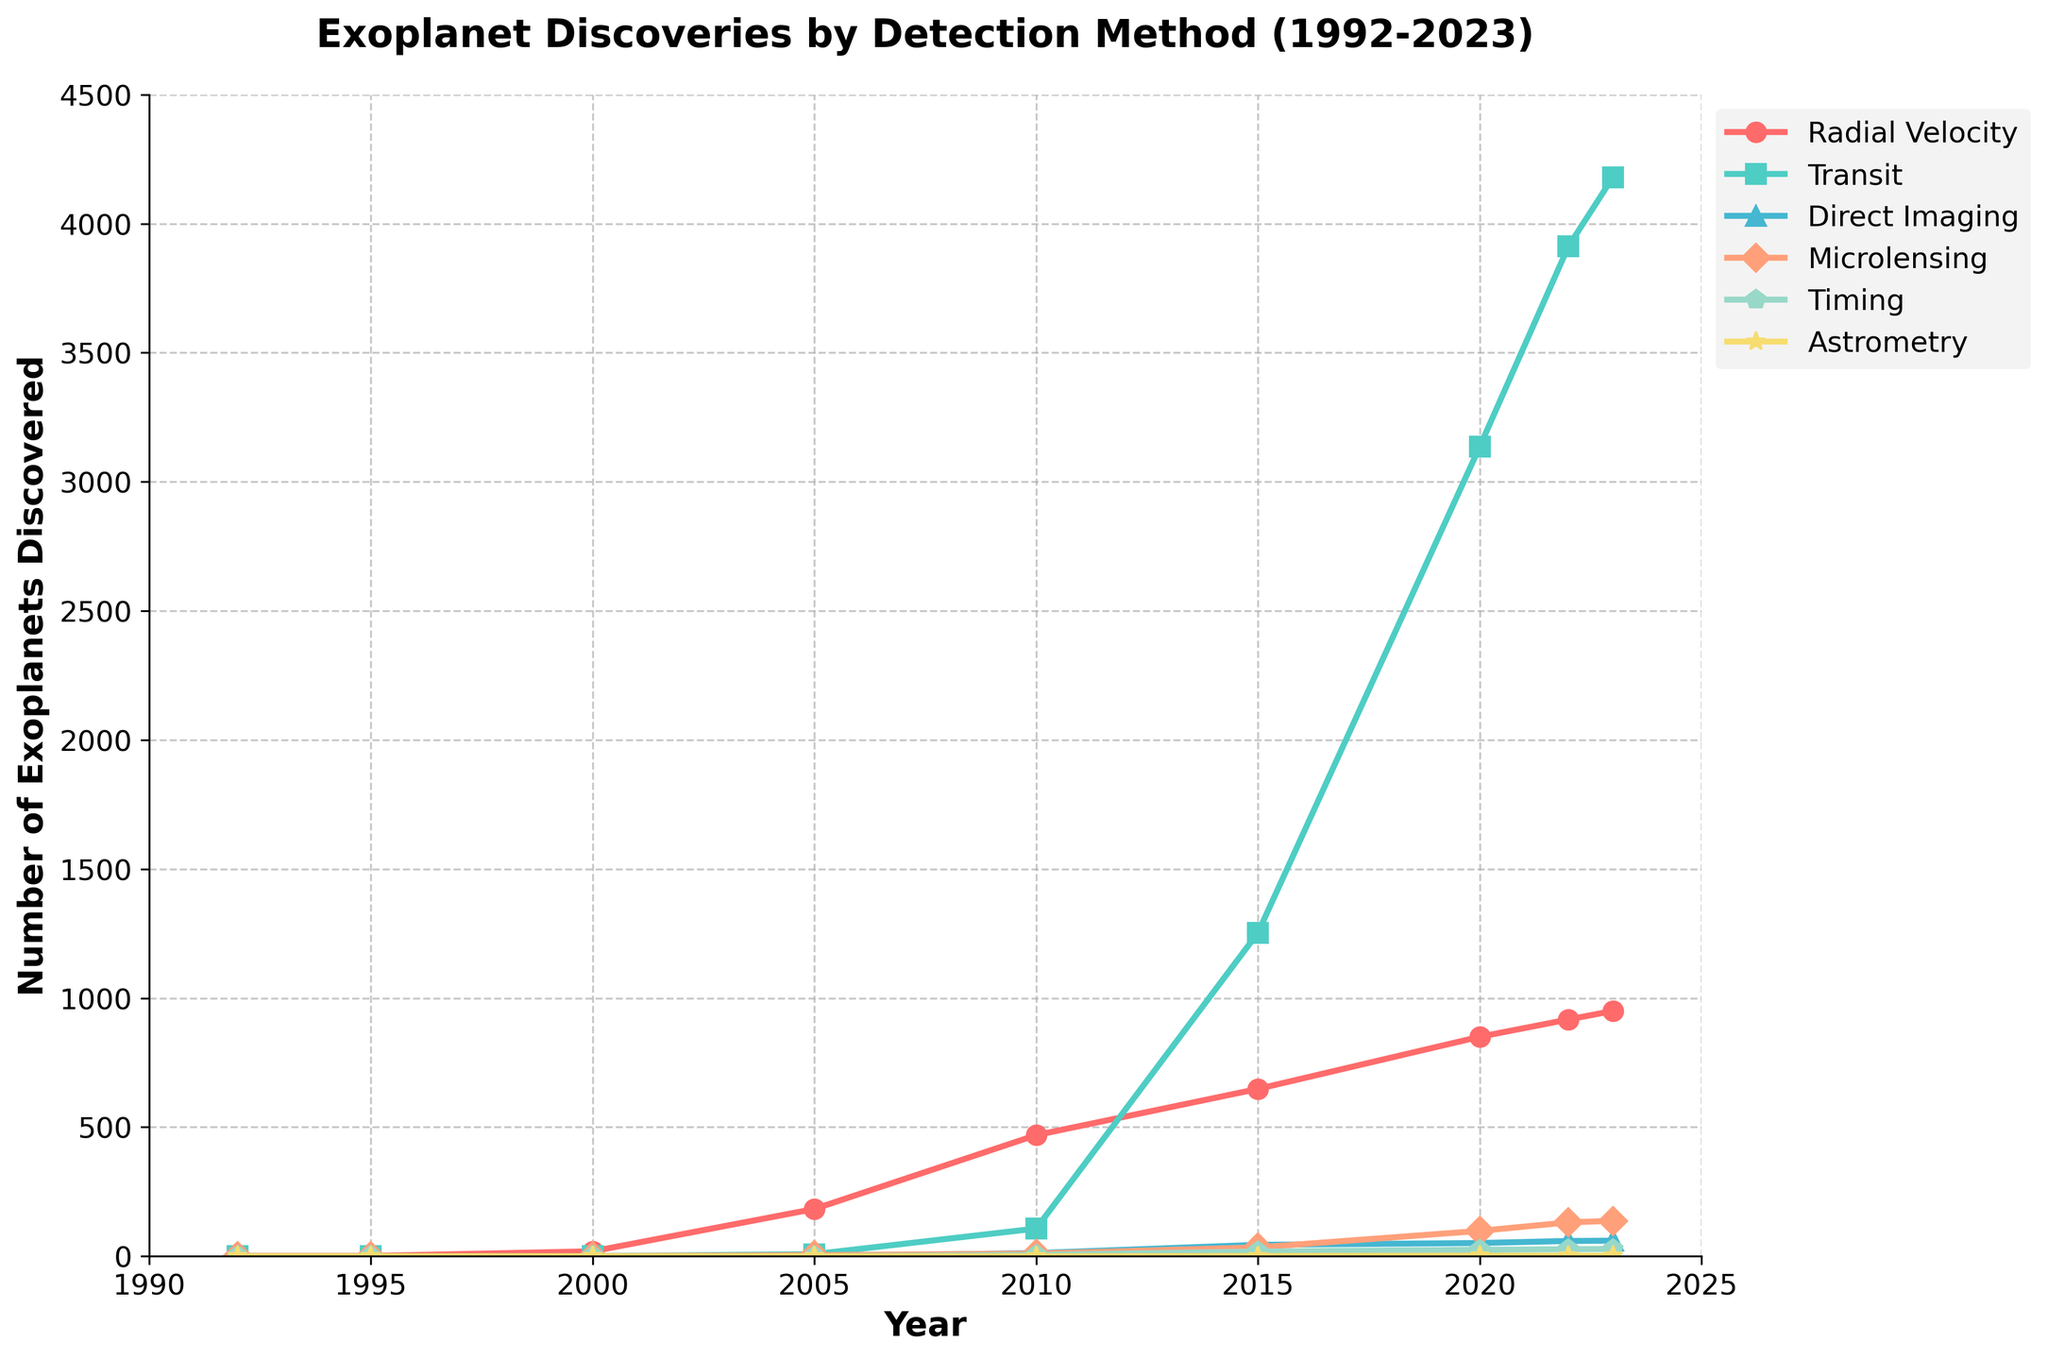What is the most common detection method used for discovering exoplanets in 2023? By looking at the data, we can see that in 2023, the "Transit" method has the highest value, which is 4179. Therefore, it is the most common detection method in 2023.
Answer: Transit Which year shows the highest number of exoplanets discovered using the Transit method? By examining the plot, we can see that 2023 has the highest number of exoplanets discovered using the Transit method, with a value of 4179.
Answer: 2023 How many exoplanets were discovered using Radial Velocity and Transit methods combined in 2015? In 2015, the number of exoplanets discovered using Radial Velocity is 648 and using Transit is 1253. Adding these, 648 + 1253 = 1901.
Answer: 1901 Compare the number of exoplanets discovered using Microlensing in 2020 and 2022. Which year had more discoveries? Checking the data for Microlensing, in 2020 it was 98 and in 2022 it was 131. Therefore, more discoveries were made using Microlensing in 2022.
Answer: 2022 What is the trend in the number of exoplanets discovered using Direct Imaging from 2005 to 2023? From the graph, the numbers for Direct Imaging rise from 0 in 2005 to 12 in 2010, then to 44 in 2015, and finally reaching 60 in 2023. This indicates a growing trend in the number of exoplanets discovered using Direct Imaging over the years.
Answer: Increasing Which detection method had the least discoveries in 2005, and how many were discovered? In 2005, the methods Microlensing, Timing, and Astrometry have 0 discoveries. Therefore, they are tied for the least discoveries.
Answer: Microlensing, Timing, Astrometry In which year did the total number of exoplanets discovered across all methods first exceed 2000? By adding the numbers for each method year by year, you will find that it first exceeds 2000 in the year 2015, where the total discoveries add up to 1253 (Transit) + 648 (Radial Velocity) + 44 (Direct Imaging) + 34 (Microlensing) + 18 (Timing) + 1 (Astrometry) = 1998, which is close. In 2020, the number exceeds 2000 significantly with 3136 (Transit) + 850 (Radial Velocity) + 51 (Direct Imaging) + 98 (Microlensing) + 25 (Timing) + 2 (Astrometry) = 4162.
Answer: 2020 